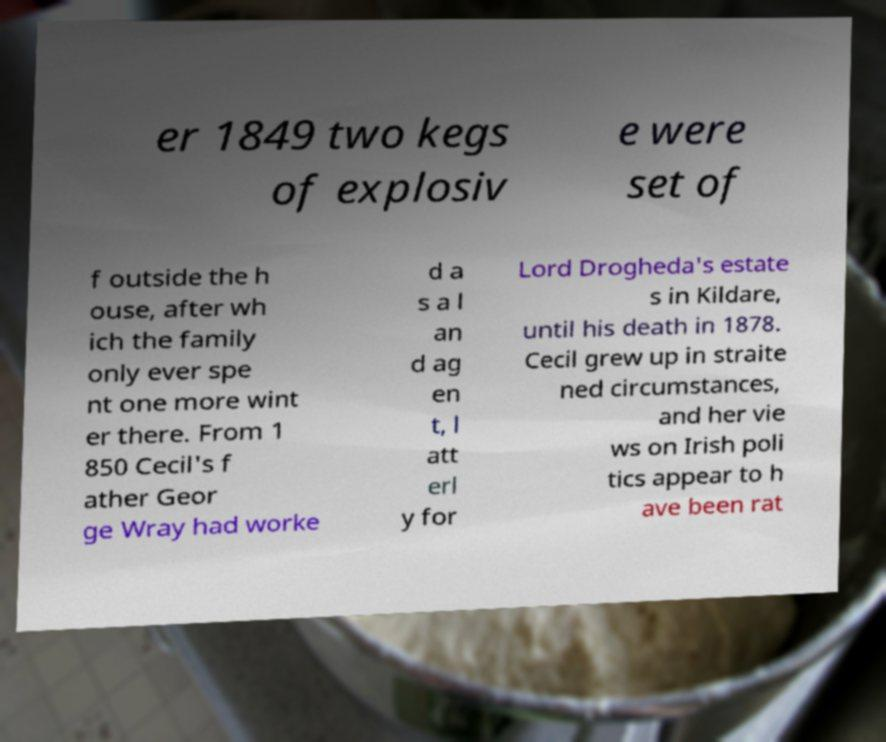Could you extract and type out the text from this image? er 1849 two kegs of explosiv e were set of f outside the h ouse, after wh ich the family only ever spe nt one more wint er there. From 1 850 Cecil's f ather Geor ge Wray had worke d a s a l an d ag en t, l att erl y for Lord Drogheda's estate s in Kildare, until his death in 1878. Cecil grew up in straite ned circumstances, and her vie ws on Irish poli tics appear to h ave been rat 